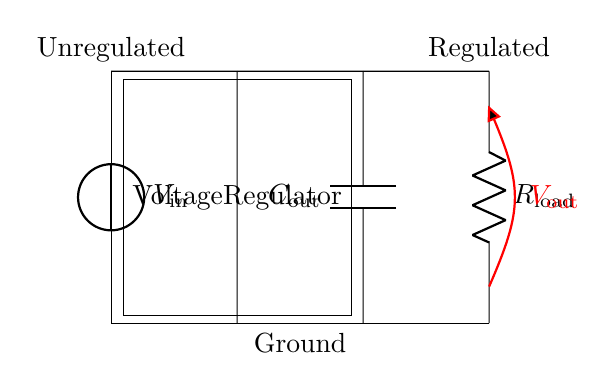What is the input voltage in the circuit? The input voltage is represented by the voltage source labeled as V-in, which is placed at the left side of the circuit.
Answer: V-in What is the function of the voltage regulator? The voltage regulator is a component that maintains a constant output voltage despite variations in the input voltage or load conditions, and it is represented in the circuit diagram.
Answer: Maintain constant voltage What component is used for filtering the output voltage? The capacitor labeled as C-out is used for filtering the output voltage, ensuring smooth operation by reducing voltage fluctuations.
Answer: C-out What is the load in this circuit? The load is represented by the resistor labeled as R-load, which consumes the regulated output voltage provided by the voltage regulator.
Answer: R-load How many output terminals are in this circuit? There are two output terminals in the circuit: one connected to V-out and another connected to ground, which means the circuit has two places to measure output.
Answer: Two What is the purpose of using a capacitor in this circuit? The purpose of the capacitor, C-out, in this circuit is to smoothen the variations in voltage and stabilize the output by temporarily storing charge.
Answer: Stabilize output voltage What is connected to the output of the voltage regulator? The output of the voltage regulator is connected to the capacitor C-out and then to the load resistor R-load, indicating that these components utilize the regulated voltage.
Answer: Capacitor and load 